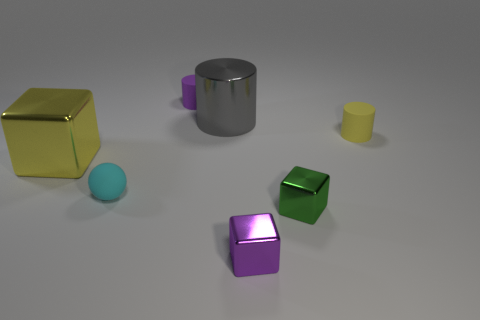What number of yellow metallic objects are the same size as the gray thing?
Your answer should be compact. 1. The matte thing that is the same color as the large block is what size?
Your response must be concise. Small. There is a metallic object that is both behind the matte sphere and in front of the gray shiny cylinder; how big is it?
Offer a terse response. Large. What number of tiny purple cylinders are in front of the large yellow thing that is to the left of the small cylinder that is in front of the shiny cylinder?
Give a very brief answer. 0. Are there any big metallic cylinders that have the same color as the big shiny cube?
Offer a terse response. No. What is the color of the other metallic object that is the same size as the gray object?
Provide a succinct answer. Yellow. What shape is the big metal object that is on the right side of the tiny matte ball to the left of the tiny cube that is left of the small green shiny cube?
Your answer should be compact. Cylinder. How many green blocks are to the left of the yellow metal cube that is behind the small green metallic object?
Give a very brief answer. 0. Does the small purple thing behind the big yellow cube have the same shape as the rubber object that is to the right of the tiny purple matte thing?
Give a very brief answer. Yes. How many big metal things are right of the yellow cube?
Your response must be concise. 1. 